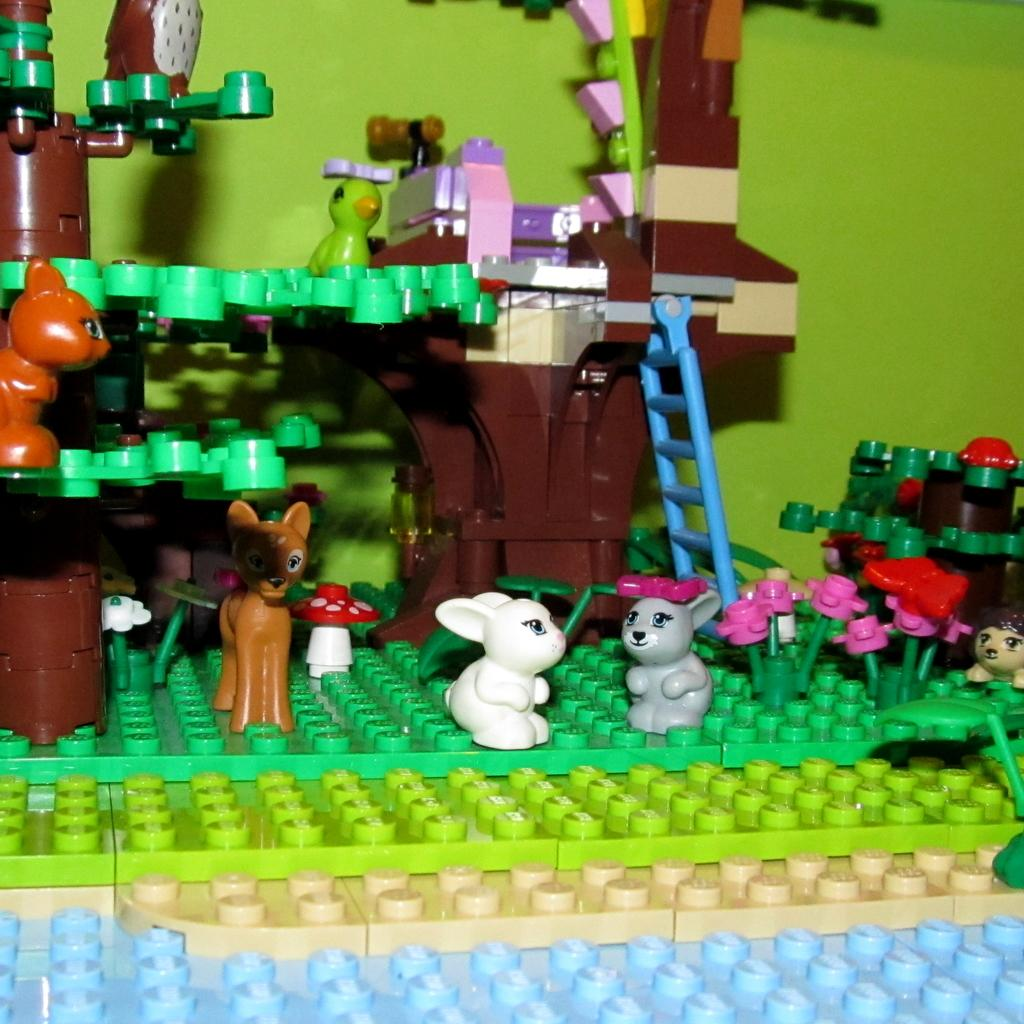What type of game is shown in the image? The image depicts a puzzle game. What kind of toys are included in the game? There are different animal toys in the game. Are there any plants in the game? Yes, flower plants are present in the game. What additional feature is included in the game? A ladder is included in the game. Can you describe the background of the image? There is a green color wall in the background. How many dolls are placed on the ladder in the image? There are no dolls present in the image; it features a puzzle game with animal toys, flower plants, and a ladder. 